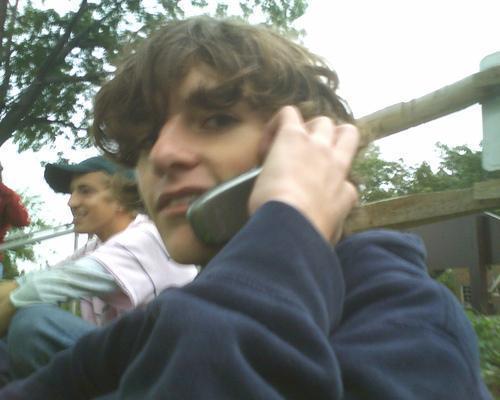How many people holding a phone?
Give a very brief answer. 1. How many people are visible?
Give a very brief answer. 2. 